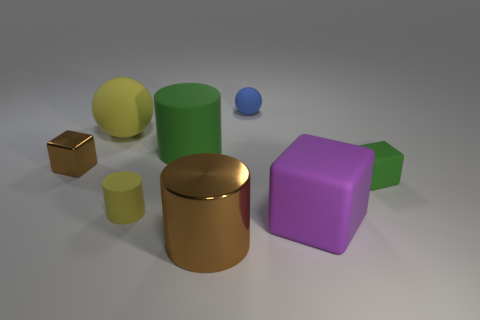What shapes are represented among the objects? The objects come in several different shapes: there are spherical, cylindrical, and cubic shapes providing a geometric diversity. 